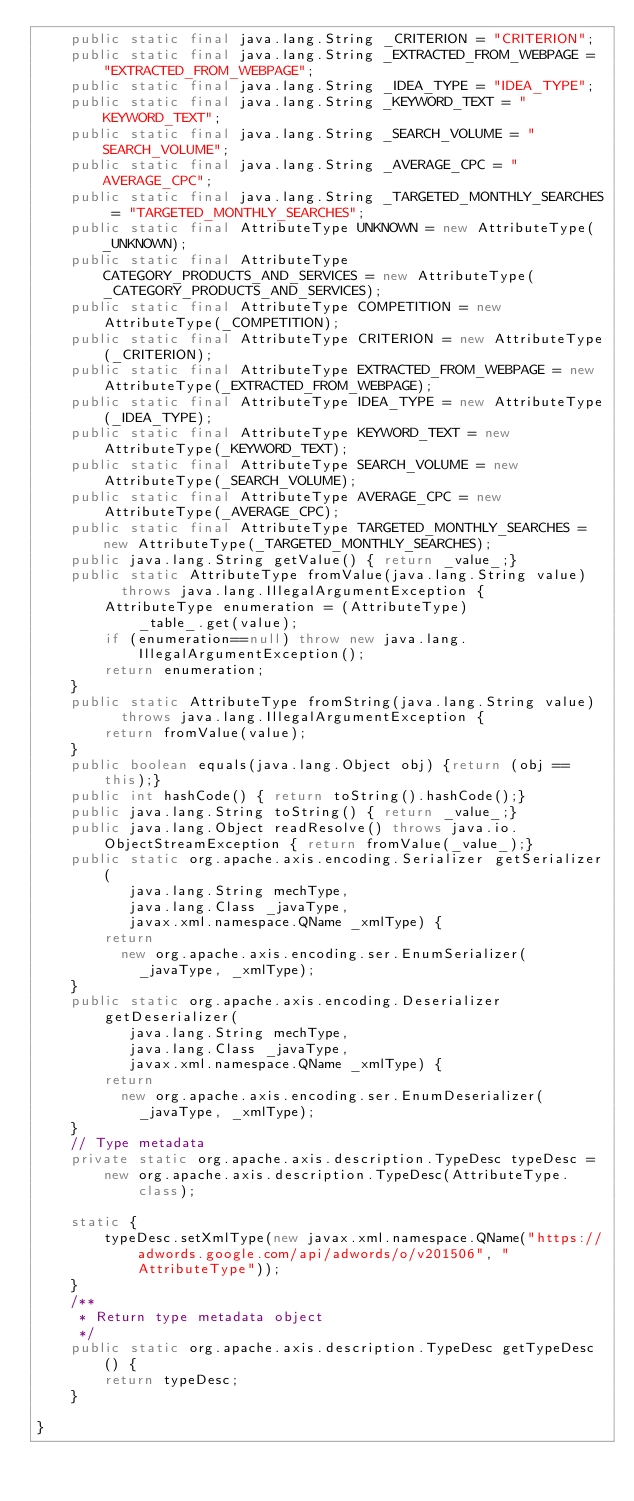Convert code to text. <code><loc_0><loc_0><loc_500><loc_500><_Java_>    public static final java.lang.String _CRITERION = "CRITERION";
    public static final java.lang.String _EXTRACTED_FROM_WEBPAGE = "EXTRACTED_FROM_WEBPAGE";
    public static final java.lang.String _IDEA_TYPE = "IDEA_TYPE";
    public static final java.lang.String _KEYWORD_TEXT = "KEYWORD_TEXT";
    public static final java.lang.String _SEARCH_VOLUME = "SEARCH_VOLUME";
    public static final java.lang.String _AVERAGE_CPC = "AVERAGE_CPC";
    public static final java.lang.String _TARGETED_MONTHLY_SEARCHES = "TARGETED_MONTHLY_SEARCHES";
    public static final AttributeType UNKNOWN = new AttributeType(_UNKNOWN);
    public static final AttributeType CATEGORY_PRODUCTS_AND_SERVICES = new AttributeType(_CATEGORY_PRODUCTS_AND_SERVICES);
    public static final AttributeType COMPETITION = new AttributeType(_COMPETITION);
    public static final AttributeType CRITERION = new AttributeType(_CRITERION);
    public static final AttributeType EXTRACTED_FROM_WEBPAGE = new AttributeType(_EXTRACTED_FROM_WEBPAGE);
    public static final AttributeType IDEA_TYPE = new AttributeType(_IDEA_TYPE);
    public static final AttributeType KEYWORD_TEXT = new AttributeType(_KEYWORD_TEXT);
    public static final AttributeType SEARCH_VOLUME = new AttributeType(_SEARCH_VOLUME);
    public static final AttributeType AVERAGE_CPC = new AttributeType(_AVERAGE_CPC);
    public static final AttributeType TARGETED_MONTHLY_SEARCHES = new AttributeType(_TARGETED_MONTHLY_SEARCHES);
    public java.lang.String getValue() { return _value_;}
    public static AttributeType fromValue(java.lang.String value)
          throws java.lang.IllegalArgumentException {
        AttributeType enumeration = (AttributeType)
            _table_.get(value);
        if (enumeration==null) throw new java.lang.IllegalArgumentException();
        return enumeration;
    }
    public static AttributeType fromString(java.lang.String value)
          throws java.lang.IllegalArgumentException {
        return fromValue(value);
    }
    public boolean equals(java.lang.Object obj) {return (obj == this);}
    public int hashCode() { return toString().hashCode();}
    public java.lang.String toString() { return _value_;}
    public java.lang.Object readResolve() throws java.io.ObjectStreamException { return fromValue(_value_);}
    public static org.apache.axis.encoding.Serializer getSerializer(
           java.lang.String mechType, 
           java.lang.Class _javaType,  
           javax.xml.namespace.QName _xmlType) {
        return 
          new org.apache.axis.encoding.ser.EnumSerializer(
            _javaType, _xmlType);
    }
    public static org.apache.axis.encoding.Deserializer getDeserializer(
           java.lang.String mechType, 
           java.lang.Class _javaType,  
           javax.xml.namespace.QName _xmlType) {
        return 
          new org.apache.axis.encoding.ser.EnumDeserializer(
            _javaType, _xmlType);
    }
    // Type metadata
    private static org.apache.axis.description.TypeDesc typeDesc =
        new org.apache.axis.description.TypeDesc(AttributeType.class);

    static {
        typeDesc.setXmlType(new javax.xml.namespace.QName("https://adwords.google.com/api/adwords/o/v201506", "AttributeType"));
    }
    /**
     * Return type metadata object
     */
    public static org.apache.axis.description.TypeDesc getTypeDesc() {
        return typeDesc;
    }

}
</code> 